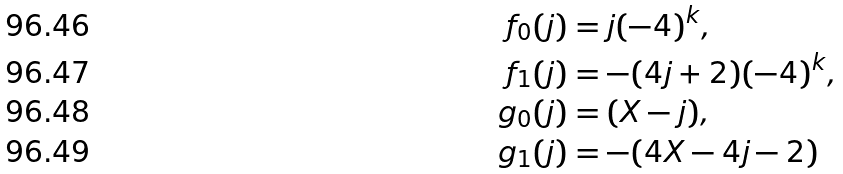Convert formula to latex. <formula><loc_0><loc_0><loc_500><loc_500>f _ { 0 } ( j ) & = j ( - 4 ) ^ { k } , \\ f _ { 1 } ( j ) & = - ( 4 j + 2 ) ( - 4 ) ^ { k } , \\ g _ { 0 } ( j ) & = ( X - j ) , \\ g _ { 1 } ( j ) & = - ( 4 X - 4 j - 2 )</formula> 